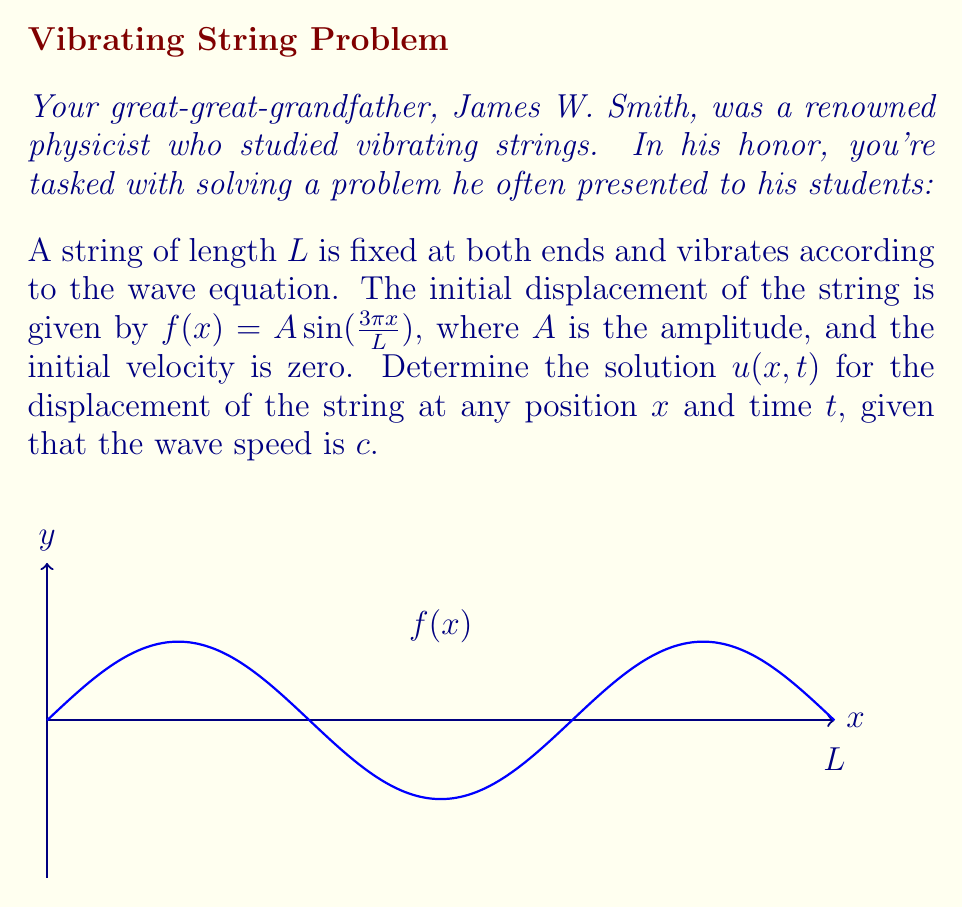Solve this math problem. Let's solve this step-by-step using the method of separation of variables:

1) The wave equation is given by:
   $$\frac{\partial^2 u}{\partial t^2} = c^2 \frac{\partial^2 u}{\partial x^2}$$

2) The boundary conditions are:
   $u(0,t) = u(L,t) = 0$ for all $t$

3) The initial conditions are:
   $u(x,0) = A \sin(\frac{3\pi x}{L})$ and $\frac{\partial u}{\partial t}(x,0) = 0$

4) We assume a solution of the form $u(x,t) = X(x)T(t)$

5) Substituting into the wave equation and separating variables:
   $$\frac{T''(t)}{c^2T(t)} = \frac{X''(x)}{X(x)} = -k^2$$

6) This gives us two ODEs:
   $X''(x) + k^2X(x) = 0$ and $T''(t) + c^2k^2T(t) = 0$

7) Solving the spatial ODE with the boundary conditions:
   $X(x) = \sin(\frac{n\pi x}{L})$, where $n$ is a positive integer

8) The temporal ODE solution is:
   $T(t) = a_n \cos(\frac{n\pi c t}{L}) + b_n \sin(\frac{n\pi c t}{L})$

9) The general solution is:
   $$u(x,t) = \sum_{n=1}^{\infty} \left(a_n \cos(\frac{n\pi c t}{L}) + b_n \sin(\frac{n\pi c t}{L})\right) \sin(\frac{n\pi x}{L})$$

10) Using the initial conditions:
    $u(x,0) = A \sin(\frac{3\pi x}{L}) = \sum_{n=1}^{\infty} a_n \sin(\frac{n\pi x}{L})$
    This implies $a_3 = A$ and all other $a_n = 0$

11) $\frac{\partial u}{\partial t}(x,0) = 0$ implies all $b_n = 0$

Therefore, the final solution is:
$$u(x,t) = A \cos(\frac{3\pi c t}{L}) \sin(\frac{3\pi x}{L})$$
Answer: $u(x,t) = A \cos(\frac{3\pi c t}{L}) \sin(\frac{3\pi x}{L})$ 